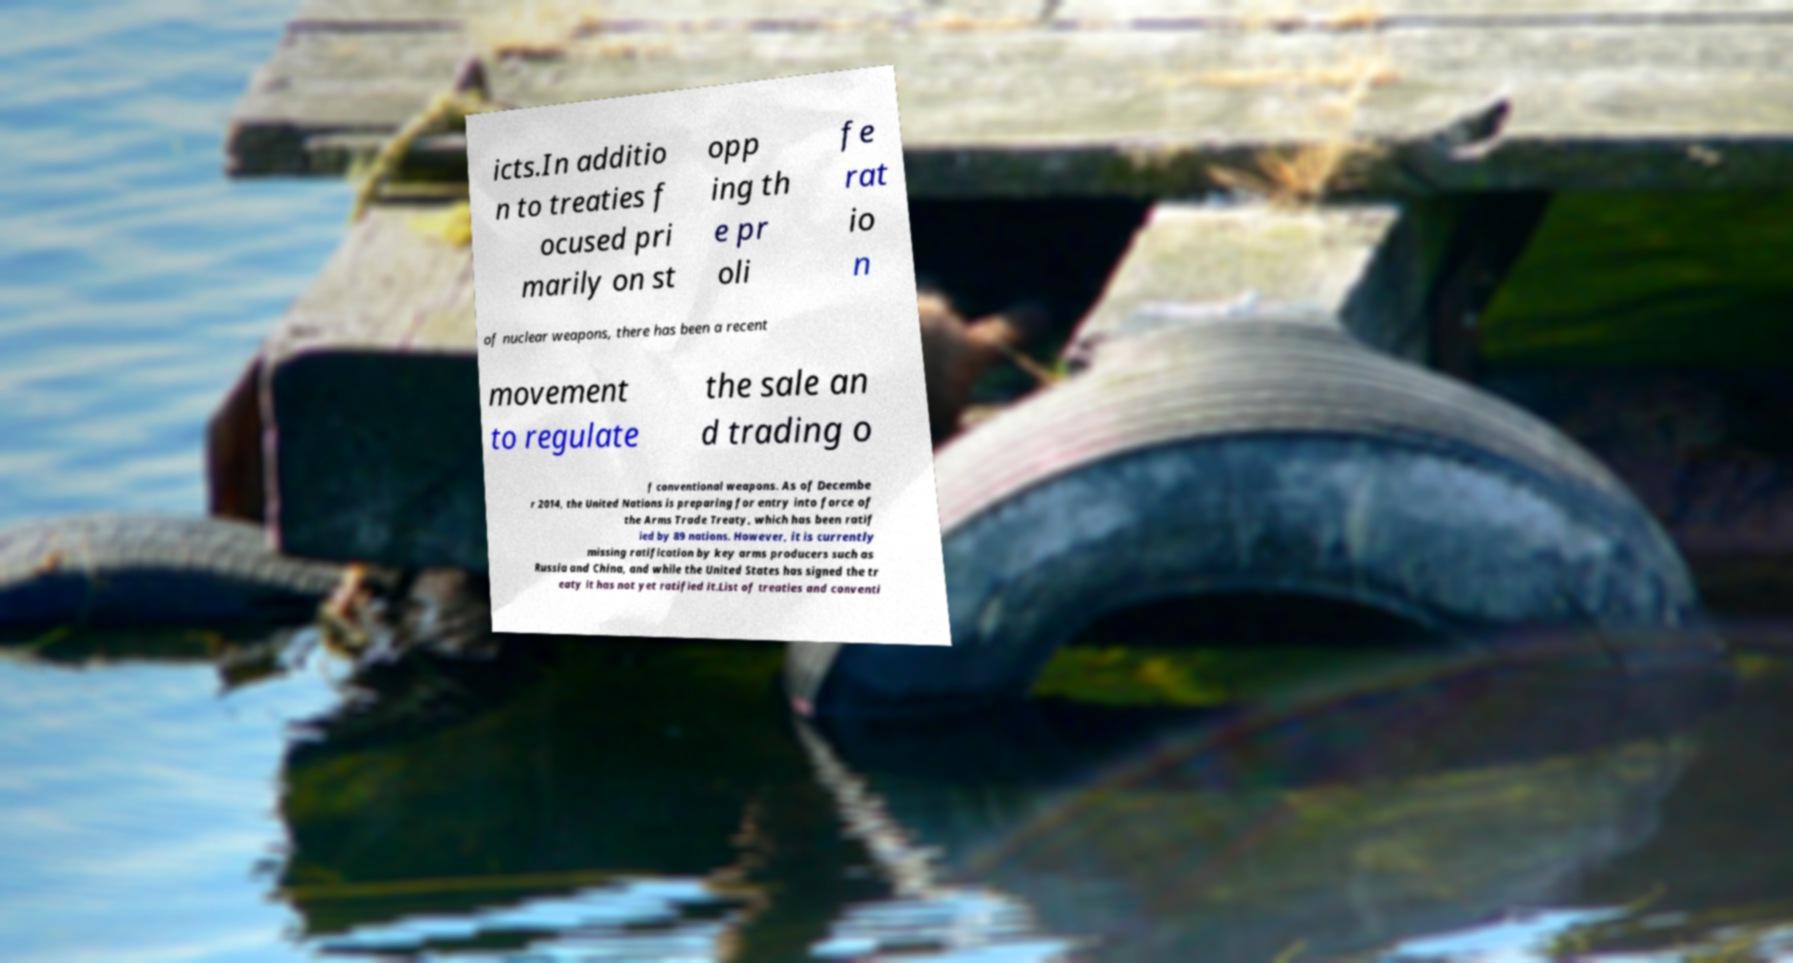Please read and relay the text visible in this image. What does it say? icts.In additio n to treaties f ocused pri marily on st opp ing th e pr oli fe rat io n of nuclear weapons, there has been a recent movement to regulate the sale an d trading o f conventional weapons. As of Decembe r 2014, the United Nations is preparing for entry into force of the Arms Trade Treaty, which has been ratif ied by 89 nations. However, it is currently missing ratification by key arms producers such as Russia and China, and while the United States has signed the tr eaty it has not yet ratified it.List of treaties and conventi 